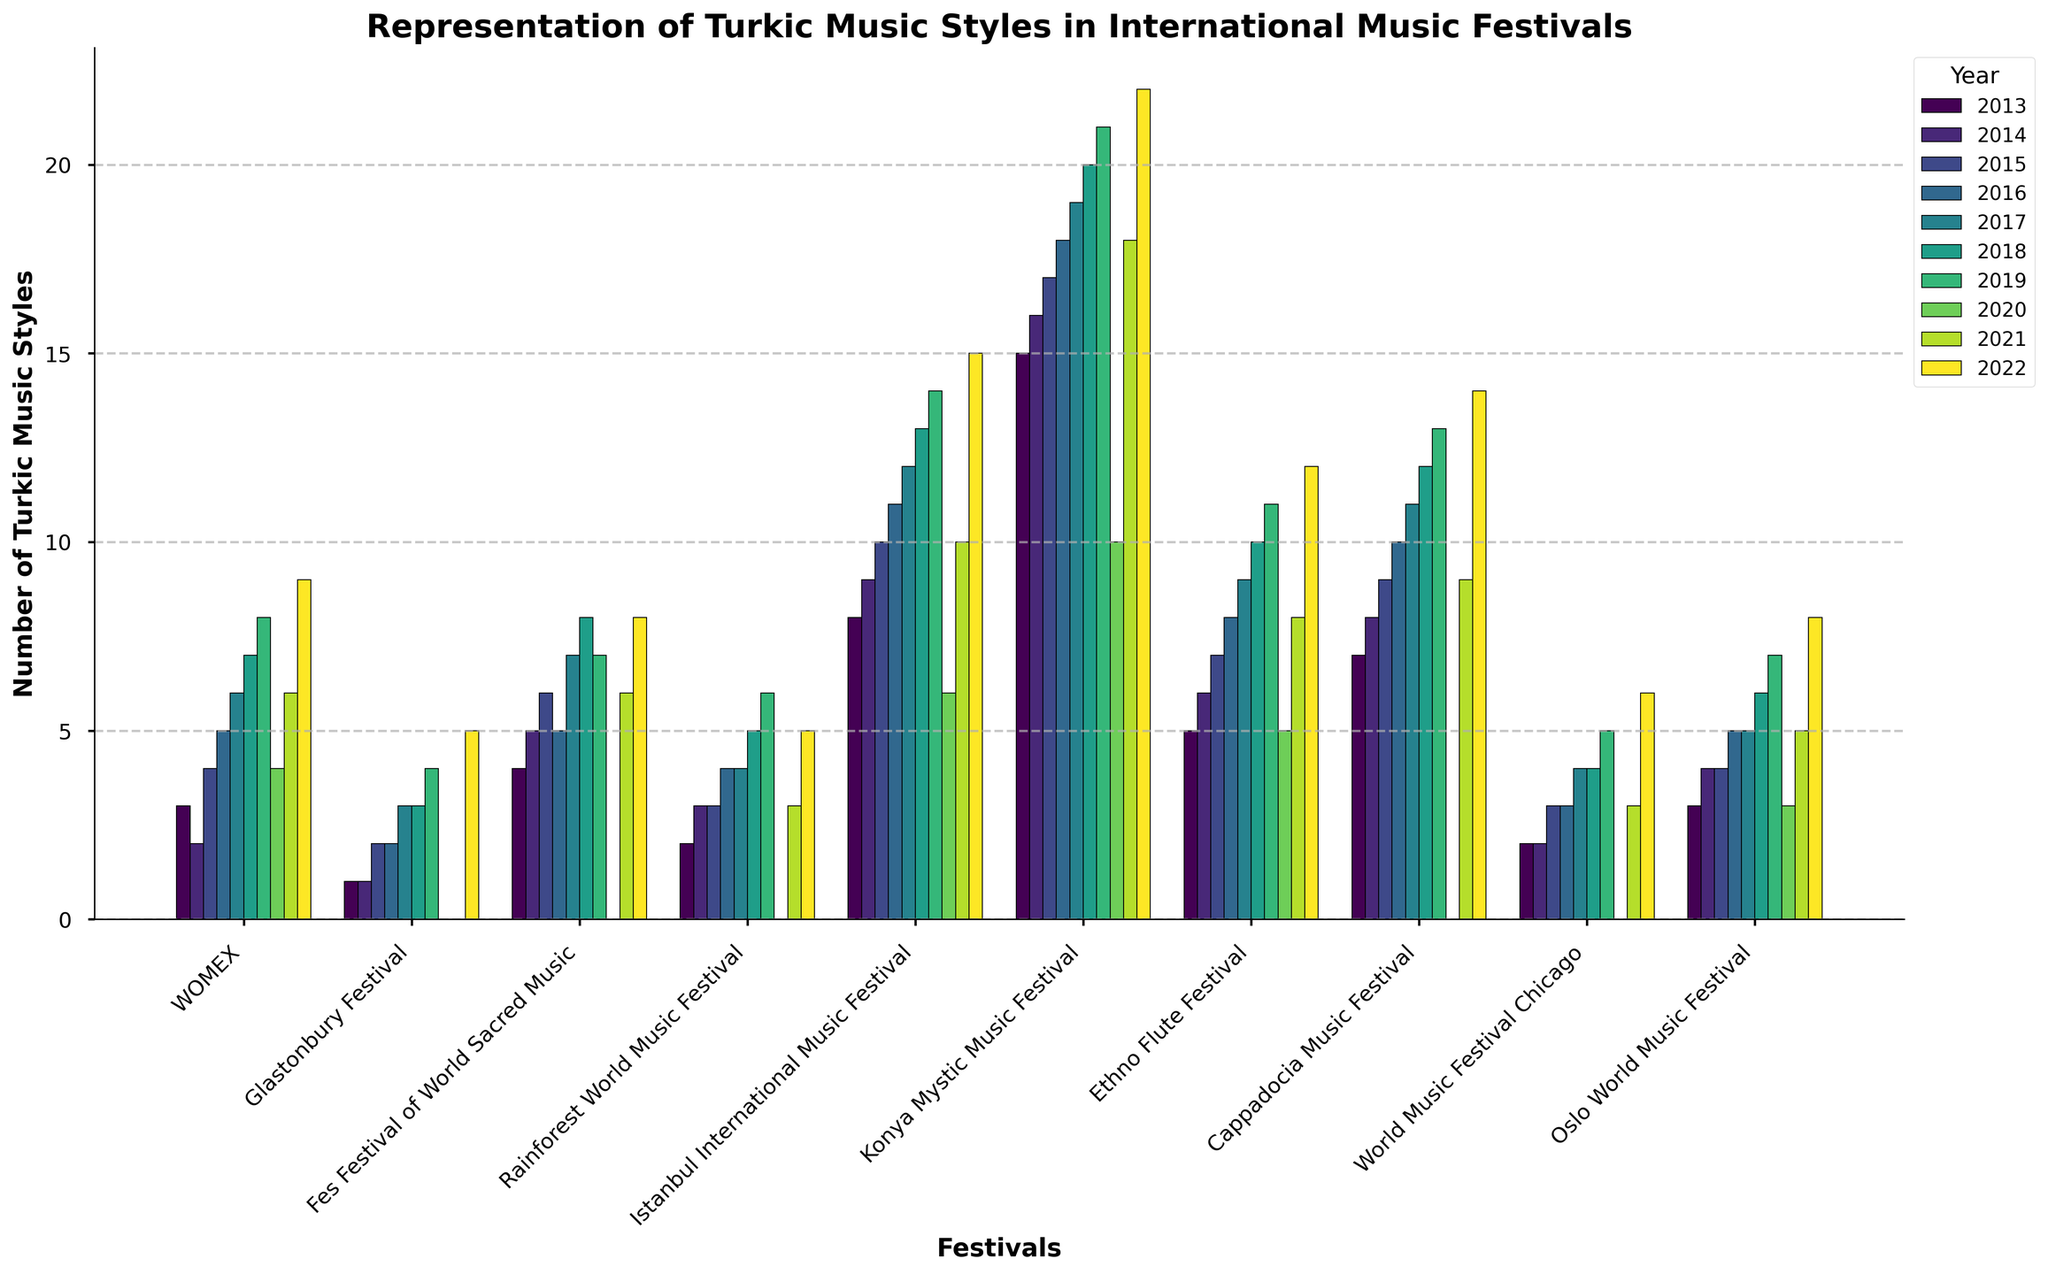What is the general trend in the representation of Turkic music styles at the Istanbul International Music Festival from 2013 to 2022? The bars for the Istanbul International Music Festival show a steadily increasing trend from 2013 to 2022, with a notable dip in 2020 but it rebounds in 2021 and 2022. From the figure, the values increase yearly except for the drop in 2020.
Answer: Increasing Comparing 2013 and 2022, which festival had the greatest increase in the number of Turkic music styles represented? By comparing the heights of the bars for 2013 and 2022 for all festivals, the Konya Mystic Music Festival shows the greatest increase, rising from 15 in 2013 to 22 in 2022.
Answer: Konya Mystic Music Festival In which year did the Cappadocia Music Festival have no representation of Turkic music styles? The bar for Cappadocia Music Festival shows zero in 2020, indicating no representation in that year.
Answer: 2020 What is the average number of Turkic music styles represented in the WOMEX festival from 2013 to 2022? To find the average, sum the values for the WOMEX festival from 2013 to 2022 (3+2+4+5+6+7+8+4+6+9 = 54) and divide by the number of years (10): 54/10 = 5.4.
Answer: 5.4 Which two festivals had no representation of Turkic music styles in 2020? From the figure, the Fes Festival of World Sacred Music and Cappadocia Music Festival both have bars with zero height for 2020.
Answer: Fes Festival of World Sacred Music, Cappadocia Music Festival What was the difference in the number of Turkic music styles represented at the Glastonbury Festival between 2013 and 2018? The number for Glastonbury Festival in 2013 is 1 and in 2018 it is 3. The difference is \( 3 - 1 = 2 \).
Answer: 2 Which festival had the highest number of Turkic music styles represented in 2019 and how many were represented? The tallest bar in 2019 is for the Konya Mystic Music Festival with 21 Turkic music styles represented.
Answer: Konya Mystic Music Festival, 21 What was the total number of Turkic music styles represented in all festivals in 2022? Sum the values for all festivals in 2022 (9+5+8+5+15+22+12+14+6+8 = 104).
Answer: 104 What trend can be observed for the representation of Turkic music styles in the Oslo World Music Festival from 2013 to 2022? The bars for the Oslo World Music Festival generally show an increasing trend from 2013 to 2022, with a small dip observed in 2020, but the rise continues in subsequent years.
Answer: Increasing 